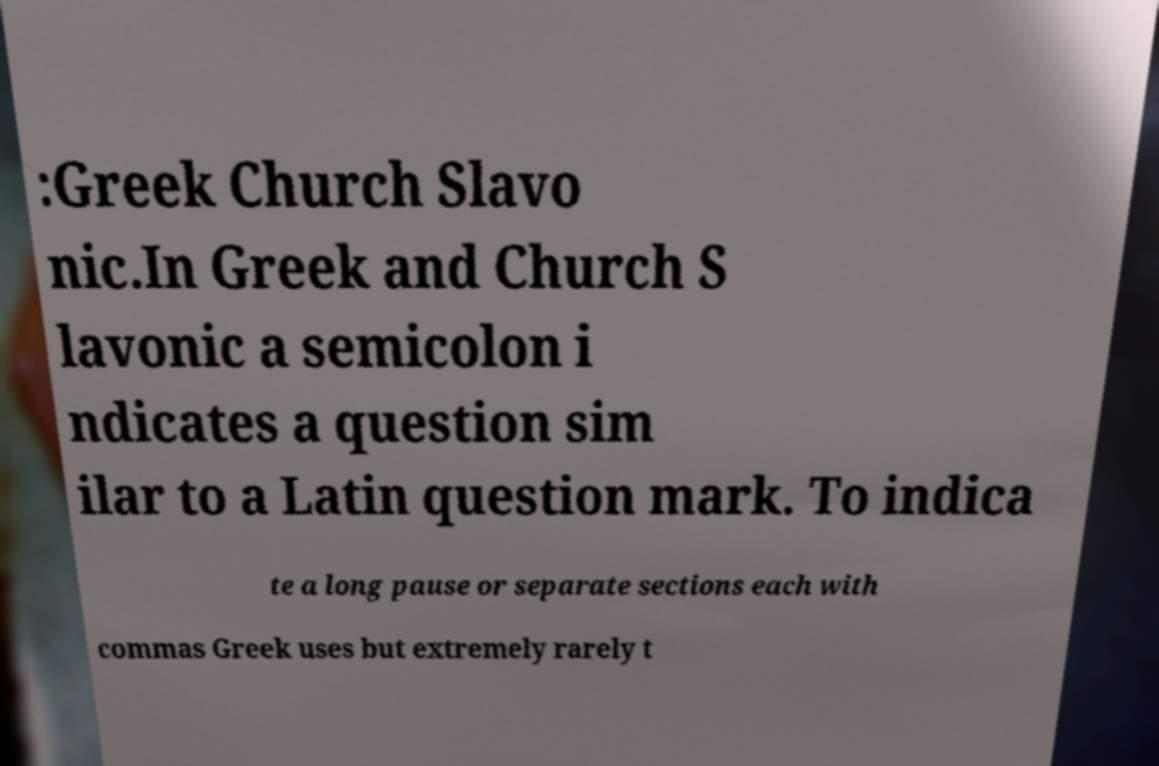Can you accurately transcribe the text from the provided image for me? :Greek Church Slavo nic.In Greek and Church S lavonic a semicolon i ndicates a question sim ilar to a Latin question mark. To indica te a long pause or separate sections each with commas Greek uses but extremely rarely t 